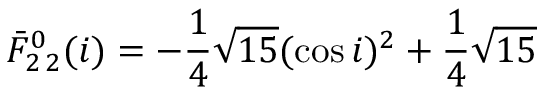Convert formula to latex. <formula><loc_0><loc_0><loc_500><loc_500>\bar { F } _ { 2 \, 2 } ^ { 0 } ( i ) = - \frac { 1 } { 4 } \sqrt { 1 5 } ( \cos i ) ^ { 2 } + \frac { 1 } { 4 } \sqrt { 1 5 }</formula> 